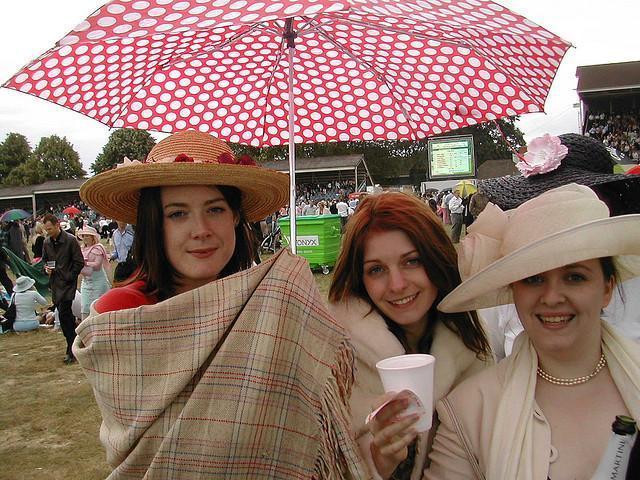How many people are in the photo?
Give a very brief answer. 5. How many dogs are running in the surf?
Give a very brief answer. 0. 